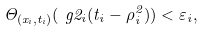Convert formula to latex. <formula><loc_0><loc_0><loc_500><loc_500>\Theta _ { ( x _ { i } , t _ { i } ) } ( \ g 2 _ { i } ( t _ { i } - \rho _ { i } ^ { 2 } ) ) < \varepsilon _ { i } ,</formula> 